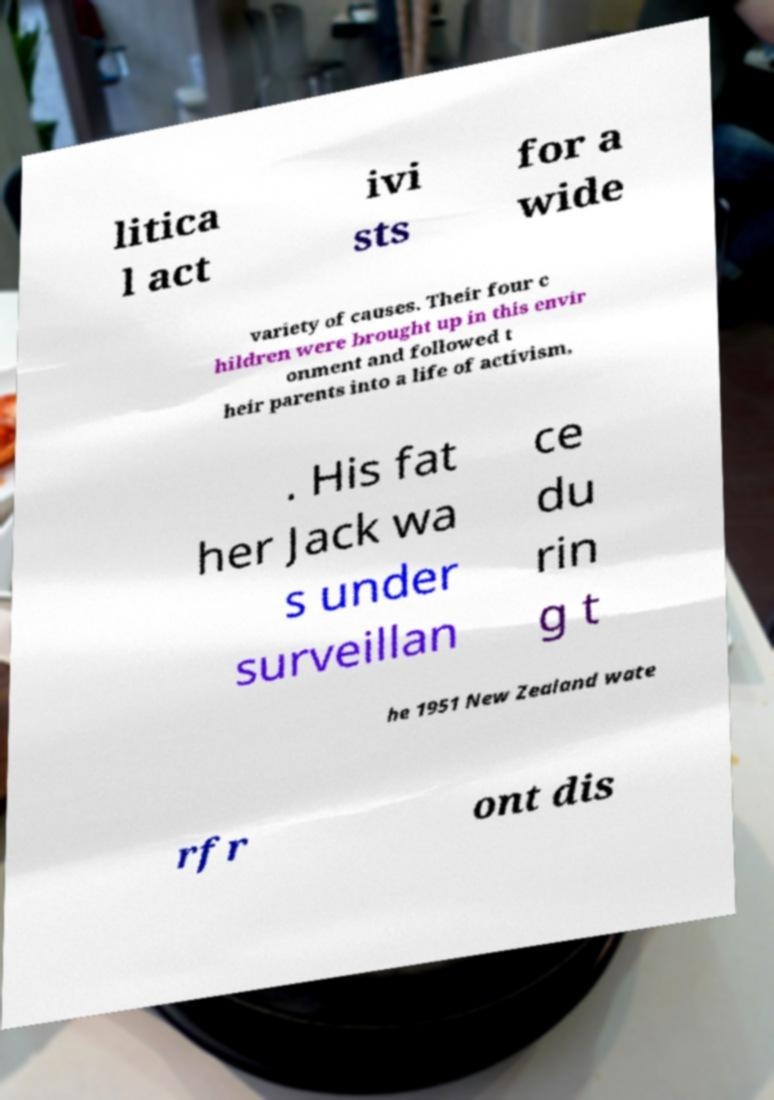I need the written content from this picture converted into text. Can you do that? litica l act ivi sts for a wide variety of causes. Their four c hildren were brought up in this envir onment and followed t heir parents into a life of activism, . His fat her Jack wa s under surveillan ce du rin g t he 1951 New Zealand wate rfr ont dis 